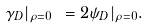<formula> <loc_0><loc_0><loc_500><loc_500>\gamma _ { D } | _ { \rho = 0 } \ = 2 \psi _ { D } | _ { \rho = 0 } .</formula> 